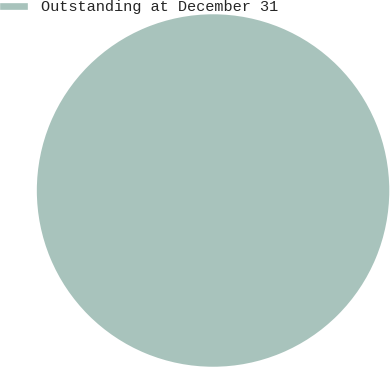Convert chart to OTSL. <chart><loc_0><loc_0><loc_500><loc_500><pie_chart><fcel>Outstanding at December 31<nl><fcel>100.0%<nl></chart> 